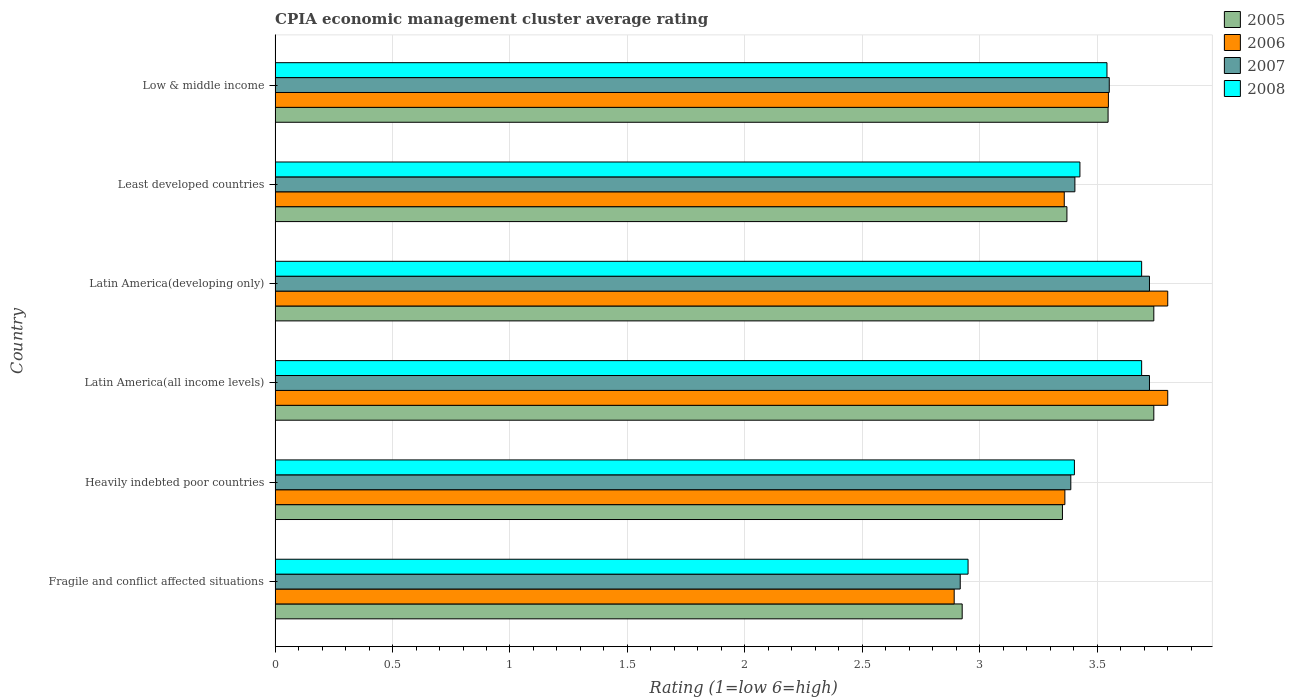How many groups of bars are there?
Make the answer very short. 6. Are the number of bars per tick equal to the number of legend labels?
Your answer should be very brief. Yes. Are the number of bars on each tick of the Y-axis equal?
Give a very brief answer. Yes. How many bars are there on the 6th tick from the top?
Your answer should be compact. 4. What is the CPIA rating in 2007 in Fragile and conflict affected situations?
Ensure brevity in your answer.  2.92. Across all countries, what is the maximum CPIA rating in 2008?
Give a very brief answer. 3.69. Across all countries, what is the minimum CPIA rating in 2007?
Give a very brief answer. 2.92. In which country was the CPIA rating in 2007 maximum?
Provide a short and direct response. Latin America(all income levels). In which country was the CPIA rating in 2005 minimum?
Provide a short and direct response. Fragile and conflict affected situations. What is the total CPIA rating in 2007 in the graph?
Offer a terse response. 20.7. What is the difference between the CPIA rating in 2008 in Heavily indebted poor countries and that in Least developed countries?
Your response must be concise. -0.02. What is the difference between the CPIA rating in 2006 in Fragile and conflict affected situations and the CPIA rating in 2008 in Least developed countries?
Offer a very short reply. -0.54. What is the average CPIA rating in 2005 per country?
Provide a short and direct response. 3.45. What is the difference between the CPIA rating in 2005 and CPIA rating in 2008 in Latin America(developing only)?
Your answer should be very brief. 0.05. What is the ratio of the CPIA rating in 2006 in Latin America(developing only) to that in Low & middle income?
Your answer should be very brief. 1.07. Is the difference between the CPIA rating in 2005 in Latin America(all income levels) and Low & middle income greater than the difference between the CPIA rating in 2008 in Latin America(all income levels) and Low & middle income?
Provide a succinct answer. Yes. What is the difference between the highest and the lowest CPIA rating in 2005?
Ensure brevity in your answer.  0.82. Is the sum of the CPIA rating in 2008 in Latin America(all income levels) and Least developed countries greater than the maximum CPIA rating in 2007 across all countries?
Your answer should be compact. Yes. Is it the case that in every country, the sum of the CPIA rating in 2006 and CPIA rating in 2008 is greater than the sum of CPIA rating in 2007 and CPIA rating in 2005?
Make the answer very short. No. What does the 4th bar from the top in Latin America(all income levels) represents?
Offer a terse response. 2005. What does the 3rd bar from the bottom in Low & middle income represents?
Make the answer very short. 2007. Does the graph contain any zero values?
Provide a succinct answer. No. How are the legend labels stacked?
Provide a succinct answer. Vertical. What is the title of the graph?
Your response must be concise. CPIA economic management cluster average rating. Does "2005" appear as one of the legend labels in the graph?
Provide a short and direct response. Yes. What is the Rating (1=low 6=high) of 2005 in Fragile and conflict affected situations?
Your answer should be very brief. 2.92. What is the Rating (1=low 6=high) of 2006 in Fragile and conflict affected situations?
Keep it short and to the point. 2.89. What is the Rating (1=low 6=high) in 2007 in Fragile and conflict affected situations?
Your response must be concise. 2.92. What is the Rating (1=low 6=high) in 2008 in Fragile and conflict affected situations?
Make the answer very short. 2.95. What is the Rating (1=low 6=high) in 2005 in Heavily indebted poor countries?
Give a very brief answer. 3.35. What is the Rating (1=low 6=high) of 2006 in Heavily indebted poor countries?
Provide a short and direct response. 3.36. What is the Rating (1=low 6=high) in 2007 in Heavily indebted poor countries?
Ensure brevity in your answer.  3.39. What is the Rating (1=low 6=high) in 2008 in Heavily indebted poor countries?
Make the answer very short. 3.4. What is the Rating (1=low 6=high) of 2005 in Latin America(all income levels)?
Keep it short and to the point. 3.74. What is the Rating (1=low 6=high) of 2006 in Latin America(all income levels)?
Your answer should be very brief. 3.8. What is the Rating (1=low 6=high) of 2007 in Latin America(all income levels)?
Provide a succinct answer. 3.72. What is the Rating (1=low 6=high) of 2008 in Latin America(all income levels)?
Ensure brevity in your answer.  3.69. What is the Rating (1=low 6=high) in 2005 in Latin America(developing only)?
Provide a succinct answer. 3.74. What is the Rating (1=low 6=high) in 2006 in Latin America(developing only)?
Your response must be concise. 3.8. What is the Rating (1=low 6=high) of 2007 in Latin America(developing only)?
Your answer should be compact. 3.72. What is the Rating (1=low 6=high) in 2008 in Latin America(developing only)?
Offer a terse response. 3.69. What is the Rating (1=low 6=high) of 2005 in Least developed countries?
Keep it short and to the point. 3.37. What is the Rating (1=low 6=high) of 2006 in Least developed countries?
Your response must be concise. 3.36. What is the Rating (1=low 6=high) in 2007 in Least developed countries?
Give a very brief answer. 3.4. What is the Rating (1=low 6=high) of 2008 in Least developed countries?
Make the answer very short. 3.43. What is the Rating (1=low 6=high) in 2005 in Low & middle income?
Keep it short and to the point. 3.55. What is the Rating (1=low 6=high) in 2006 in Low & middle income?
Your answer should be compact. 3.55. What is the Rating (1=low 6=high) in 2007 in Low & middle income?
Make the answer very short. 3.55. What is the Rating (1=low 6=high) in 2008 in Low & middle income?
Your answer should be very brief. 3.54. Across all countries, what is the maximum Rating (1=low 6=high) of 2005?
Your response must be concise. 3.74. Across all countries, what is the maximum Rating (1=low 6=high) of 2007?
Your answer should be very brief. 3.72. Across all countries, what is the maximum Rating (1=low 6=high) of 2008?
Your answer should be compact. 3.69. Across all countries, what is the minimum Rating (1=low 6=high) in 2005?
Provide a succinct answer. 2.92. Across all countries, what is the minimum Rating (1=low 6=high) of 2006?
Your response must be concise. 2.89. Across all countries, what is the minimum Rating (1=low 6=high) of 2007?
Your answer should be compact. 2.92. Across all countries, what is the minimum Rating (1=low 6=high) of 2008?
Give a very brief answer. 2.95. What is the total Rating (1=low 6=high) of 2005 in the graph?
Your response must be concise. 20.68. What is the total Rating (1=low 6=high) in 2006 in the graph?
Your answer should be very brief. 20.76. What is the total Rating (1=low 6=high) of 2007 in the graph?
Ensure brevity in your answer.  20.7. What is the total Rating (1=low 6=high) of 2008 in the graph?
Make the answer very short. 20.7. What is the difference between the Rating (1=low 6=high) in 2005 in Fragile and conflict affected situations and that in Heavily indebted poor countries?
Your answer should be very brief. -0.43. What is the difference between the Rating (1=low 6=high) of 2006 in Fragile and conflict affected situations and that in Heavily indebted poor countries?
Keep it short and to the point. -0.47. What is the difference between the Rating (1=low 6=high) of 2007 in Fragile and conflict affected situations and that in Heavily indebted poor countries?
Your response must be concise. -0.47. What is the difference between the Rating (1=low 6=high) in 2008 in Fragile and conflict affected situations and that in Heavily indebted poor countries?
Offer a very short reply. -0.45. What is the difference between the Rating (1=low 6=high) of 2005 in Fragile and conflict affected situations and that in Latin America(all income levels)?
Give a very brief answer. -0.82. What is the difference between the Rating (1=low 6=high) in 2006 in Fragile and conflict affected situations and that in Latin America(all income levels)?
Your answer should be compact. -0.91. What is the difference between the Rating (1=low 6=high) in 2007 in Fragile and conflict affected situations and that in Latin America(all income levels)?
Keep it short and to the point. -0.81. What is the difference between the Rating (1=low 6=high) of 2008 in Fragile and conflict affected situations and that in Latin America(all income levels)?
Make the answer very short. -0.74. What is the difference between the Rating (1=low 6=high) of 2005 in Fragile and conflict affected situations and that in Latin America(developing only)?
Make the answer very short. -0.82. What is the difference between the Rating (1=low 6=high) in 2006 in Fragile and conflict affected situations and that in Latin America(developing only)?
Your answer should be very brief. -0.91. What is the difference between the Rating (1=low 6=high) of 2007 in Fragile and conflict affected situations and that in Latin America(developing only)?
Give a very brief answer. -0.81. What is the difference between the Rating (1=low 6=high) in 2008 in Fragile and conflict affected situations and that in Latin America(developing only)?
Ensure brevity in your answer.  -0.74. What is the difference between the Rating (1=low 6=high) in 2005 in Fragile and conflict affected situations and that in Least developed countries?
Your answer should be compact. -0.45. What is the difference between the Rating (1=low 6=high) in 2006 in Fragile and conflict affected situations and that in Least developed countries?
Your answer should be compact. -0.47. What is the difference between the Rating (1=low 6=high) in 2007 in Fragile and conflict affected situations and that in Least developed countries?
Keep it short and to the point. -0.49. What is the difference between the Rating (1=low 6=high) of 2008 in Fragile and conflict affected situations and that in Least developed countries?
Provide a short and direct response. -0.48. What is the difference between the Rating (1=low 6=high) in 2005 in Fragile and conflict affected situations and that in Low & middle income?
Keep it short and to the point. -0.62. What is the difference between the Rating (1=low 6=high) of 2006 in Fragile and conflict affected situations and that in Low & middle income?
Provide a short and direct response. -0.66. What is the difference between the Rating (1=low 6=high) of 2007 in Fragile and conflict affected situations and that in Low & middle income?
Offer a terse response. -0.63. What is the difference between the Rating (1=low 6=high) in 2008 in Fragile and conflict affected situations and that in Low & middle income?
Keep it short and to the point. -0.59. What is the difference between the Rating (1=low 6=high) in 2005 in Heavily indebted poor countries and that in Latin America(all income levels)?
Give a very brief answer. -0.39. What is the difference between the Rating (1=low 6=high) in 2006 in Heavily indebted poor countries and that in Latin America(all income levels)?
Your response must be concise. -0.44. What is the difference between the Rating (1=low 6=high) in 2007 in Heavily indebted poor countries and that in Latin America(all income levels)?
Provide a short and direct response. -0.33. What is the difference between the Rating (1=low 6=high) of 2008 in Heavily indebted poor countries and that in Latin America(all income levels)?
Keep it short and to the point. -0.29. What is the difference between the Rating (1=low 6=high) in 2005 in Heavily indebted poor countries and that in Latin America(developing only)?
Offer a terse response. -0.39. What is the difference between the Rating (1=low 6=high) of 2006 in Heavily indebted poor countries and that in Latin America(developing only)?
Ensure brevity in your answer.  -0.44. What is the difference between the Rating (1=low 6=high) of 2007 in Heavily indebted poor countries and that in Latin America(developing only)?
Make the answer very short. -0.33. What is the difference between the Rating (1=low 6=high) of 2008 in Heavily indebted poor countries and that in Latin America(developing only)?
Your response must be concise. -0.29. What is the difference between the Rating (1=low 6=high) of 2005 in Heavily indebted poor countries and that in Least developed countries?
Give a very brief answer. -0.02. What is the difference between the Rating (1=low 6=high) of 2006 in Heavily indebted poor countries and that in Least developed countries?
Provide a short and direct response. 0. What is the difference between the Rating (1=low 6=high) in 2007 in Heavily indebted poor countries and that in Least developed countries?
Make the answer very short. -0.02. What is the difference between the Rating (1=low 6=high) in 2008 in Heavily indebted poor countries and that in Least developed countries?
Ensure brevity in your answer.  -0.02. What is the difference between the Rating (1=low 6=high) of 2005 in Heavily indebted poor countries and that in Low & middle income?
Provide a succinct answer. -0.19. What is the difference between the Rating (1=low 6=high) in 2006 in Heavily indebted poor countries and that in Low & middle income?
Ensure brevity in your answer.  -0.19. What is the difference between the Rating (1=low 6=high) in 2007 in Heavily indebted poor countries and that in Low & middle income?
Offer a very short reply. -0.16. What is the difference between the Rating (1=low 6=high) in 2008 in Heavily indebted poor countries and that in Low & middle income?
Ensure brevity in your answer.  -0.14. What is the difference between the Rating (1=low 6=high) of 2005 in Latin America(all income levels) and that in Latin America(developing only)?
Your answer should be very brief. 0. What is the difference between the Rating (1=low 6=high) of 2006 in Latin America(all income levels) and that in Latin America(developing only)?
Your answer should be very brief. 0. What is the difference between the Rating (1=low 6=high) in 2005 in Latin America(all income levels) and that in Least developed countries?
Provide a succinct answer. 0.37. What is the difference between the Rating (1=low 6=high) of 2006 in Latin America(all income levels) and that in Least developed countries?
Provide a short and direct response. 0.44. What is the difference between the Rating (1=low 6=high) in 2007 in Latin America(all income levels) and that in Least developed countries?
Offer a very short reply. 0.32. What is the difference between the Rating (1=low 6=high) of 2008 in Latin America(all income levels) and that in Least developed countries?
Offer a terse response. 0.26. What is the difference between the Rating (1=low 6=high) of 2005 in Latin America(all income levels) and that in Low & middle income?
Your answer should be very brief. 0.19. What is the difference between the Rating (1=low 6=high) in 2006 in Latin America(all income levels) and that in Low & middle income?
Provide a short and direct response. 0.25. What is the difference between the Rating (1=low 6=high) of 2007 in Latin America(all income levels) and that in Low & middle income?
Keep it short and to the point. 0.17. What is the difference between the Rating (1=low 6=high) of 2008 in Latin America(all income levels) and that in Low & middle income?
Your response must be concise. 0.15. What is the difference between the Rating (1=low 6=high) in 2005 in Latin America(developing only) and that in Least developed countries?
Provide a succinct answer. 0.37. What is the difference between the Rating (1=low 6=high) in 2006 in Latin America(developing only) and that in Least developed countries?
Offer a terse response. 0.44. What is the difference between the Rating (1=low 6=high) of 2007 in Latin America(developing only) and that in Least developed countries?
Provide a succinct answer. 0.32. What is the difference between the Rating (1=low 6=high) in 2008 in Latin America(developing only) and that in Least developed countries?
Your answer should be compact. 0.26. What is the difference between the Rating (1=low 6=high) of 2005 in Latin America(developing only) and that in Low & middle income?
Your response must be concise. 0.19. What is the difference between the Rating (1=low 6=high) of 2006 in Latin America(developing only) and that in Low & middle income?
Offer a terse response. 0.25. What is the difference between the Rating (1=low 6=high) of 2007 in Latin America(developing only) and that in Low & middle income?
Offer a terse response. 0.17. What is the difference between the Rating (1=low 6=high) in 2008 in Latin America(developing only) and that in Low & middle income?
Your answer should be compact. 0.15. What is the difference between the Rating (1=low 6=high) in 2005 in Least developed countries and that in Low & middle income?
Your response must be concise. -0.18. What is the difference between the Rating (1=low 6=high) of 2006 in Least developed countries and that in Low & middle income?
Your answer should be compact. -0.19. What is the difference between the Rating (1=low 6=high) of 2007 in Least developed countries and that in Low & middle income?
Provide a succinct answer. -0.15. What is the difference between the Rating (1=low 6=high) in 2008 in Least developed countries and that in Low & middle income?
Provide a short and direct response. -0.12. What is the difference between the Rating (1=low 6=high) in 2005 in Fragile and conflict affected situations and the Rating (1=low 6=high) in 2006 in Heavily indebted poor countries?
Provide a short and direct response. -0.44. What is the difference between the Rating (1=low 6=high) of 2005 in Fragile and conflict affected situations and the Rating (1=low 6=high) of 2007 in Heavily indebted poor countries?
Provide a short and direct response. -0.46. What is the difference between the Rating (1=low 6=high) in 2005 in Fragile and conflict affected situations and the Rating (1=low 6=high) in 2008 in Heavily indebted poor countries?
Ensure brevity in your answer.  -0.48. What is the difference between the Rating (1=low 6=high) of 2006 in Fragile and conflict affected situations and the Rating (1=low 6=high) of 2007 in Heavily indebted poor countries?
Make the answer very short. -0.5. What is the difference between the Rating (1=low 6=high) in 2006 in Fragile and conflict affected situations and the Rating (1=low 6=high) in 2008 in Heavily indebted poor countries?
Give a very brief answer. -0.51. What is the difference between the Rating (1=low 6=high) of 2007 in Fragile and conflict affected situations and the Rating (1=low 6=high) of 2008 in Heavily indebted poor countries?
Ensure brevity in your answer.  -0.49. What is the difference between the Rating (1=low 6=high) of 2005 in Fragile and conflict affected situations and the Rating (1=low 6=high) of 2006 in Latin America(all income levels)?
Provide a succinct answer. -0.88. What is the difference between the Rating (1=low 6=high) of 2005 in Fragile and conflict affected situations and the Rating (1=low 6=high) of 2007 in Latin America(all income levels)?
Offer a very short reply. -0.8. What is the difference between the Rating (1=low 6=high) of 2005 in Fragile and conflict affected situations and the Rating (1=low 6=high) of 2008 in Latin America(all income levels)?
Ensure brevity in your answer.  -0.76. What is the difference between the Rating (1=low 6=high) of 2006 in Fragile and conflict affected situations and the Rating (1=low 6=high) of 2007 in Latin America(all income levels)?
Give a very brief answer. -0.83. What is the difference between the Rating (1=low 6=high) of 2006 in Fragile and conflict affected situations and the Rating (1=low 6=high) of 2008 in Latin America(all income levels)?
Ensure brevity in your answer.  -0.8. What is the difference between the Rating (1=low 6=high) in 2007 in Fragile and conflict affected situations and the Rating (1=low 6=high) in 2008 in Latin America(all income levels)?
Offer a very short reply. -0.77. What is the difference between the Rating (1=low 6=high) in 2005 in Fragile and conflict affected situations and the Rating (1=low 6=high) in 2006 in Latin America(developing only)?
Offer a terse response. -0.88. What is the difference between the Rating (1=low 6=high) of 2005 in Fragile and conflict affected situations and the Rating (1=low 6=high) of 2007 in Latin America(developing only)?
Provide a succinct answer. -0.8. What is the difference between the Rating (1=low 6=high) in 2005 in Fragile and conflict affected situations and the Rating (1=low 6=high) in 2008 in Latin America(developing only)?
Make the answer very short. -0.76. What is the difference between the Rating (1=low 6=high) of 2006 in Fragile and conflict affected situations and the Rating (1=low 6=high) of 2007 in Latin America(developing only)?
Your answer should be compact. -0.83. What is the difference between the Rating (1=low 6=high) in 2006 in Fragile and conflict affected situations and the Rating (1=low 6=high) in 2008 in Latin America(developing only)?
Your answer should be very brief. -0.8. What is the difference between the Rating (1=low 6=high) of 2007 in Fragile and conflict affected situations and the Rating (1=low 6=high) of 2008 in Latin America(developing only)?
Your response must be concise. -0.77. What is the difference between the Rating (1=low 6=high) in 2005 in Fragile and conflict affected situations and the Rating (1=low 6=high) in 2006 in Least developed countries?
Provide a short and direct response. -0.43. What is the difference between the Rating (1=low 6=high) in 2005 in Fragile and conflict affected situations and the Rating (1=low 6=high) in 2007 in Least developed countries?
Your answer should be compact. -0.48. What is the difference between the Rating (1=low 6=high) in 2005 in Fragile and conflict affected situations and the Rating (1=low 6=high) in 2008 in Least developed countries?
Keep it short and to the point. -0.5. What is the difference between the Rating (1=low 6=high) in 2006 in Fragile and conflict affected situations and the Rating (1=low 6=high) in 2007 in Least developed countries?
Your answer should be very brief. -0.51. What is the difference between the Rating (1=low 6=high) in 2006 in Fragile and conflict affected situations and the Rating (1=low 6=high) in 2008 in Least developed countries?
Ensure brevity in your answer.  -0.54. What is the difference between the Rating (1=low 6=high) of 2007 in Fragile and conflict affected situations and the Rating (1=low 6=high) of 2008 in Least developed countries?
Provide a short and direct response. -0.51. What is the difference between the Rating (1=low 6=high) in 2005 in Fragile and conflict affected situations and the Rating (1=low 6=high) in 2006 in Low & middle income?
Provide a short and direct response. -0.62. What is the difference between the Rating (1=low 6=high) of 2005 in Fragile and conflict affected situations and the Rating (1=low 6=high) of 2007 in Low & middle income?
Give a very brief answer. -0.63. What is the difference between the Rating (1=low 6=high) in 2005 in Fragile and conflict affected situations and the Rating (1=low 6=high) in 2008 in Low & middle income?
Provide a succinct answer. -0.62. What is the difference between the Rating (1=low 6=high) in 2006 in Fragile and conflict affected situations and the Rating (1=low 6=high) in 2007 in Low & middle income?
Offer a terse response. -0.66. What is the difference between the Rating (1=low 6=high) of 2006 in Fragile and conflict affected situations and the Rating (1=low 6=high) of 2008 in Low & middle income?
Your answer should be very brief. -0.65. What is the difference between the Rating (1=low 6=high) of 2007 in Fragile and conflict affected situations and the Rating (1=low 6=high) of 2008 in Low & middle income?
Give a very brief answer. -0.62. What is the difference between the Rating (1=low 6=high) in 2005 in Heavily indebted poor countries and the Rating (1=low 6=high) in 2006 in Latin America(all income levels)?
Ensure brevity in your answer.  -0.45. What is the difference between the Rating (1=low 6=high) of 2005 in Heavily indebted poor countries and the Rating (1=low 6=high) of 2007 in Latin America(all income levels)?
Give a very brief answer. -0.37. What is the difference between the Rating (1=low 6=high) in 2005 in Heavily indebted poor countries and the Rating (1=low 6=high) in 2008 in Latin America(all income levels)?
Keep it short and to the point. -0.34. What is the difference between the Rating (1=low 6=high) in 2006 in Heavily indebted poor countries and the Rating (1=low 6=high) in 2007 in Latin America(all income levels)?
Ensure brevity in your answer.  -0.36. What is the difference between the Rating (1=low 6=high) of 2006 in Heavily indebted poor countries and the Rating (1=low 6=high) of 2008 in Latin America(all income levels)?
Provide a succinct answer. -0.33. What is the difference between the Rating (1=low 6=high) in 2007 in Heavily indebted poor countries and the Rating (1=low 6=high) in 2008 in Latin America(all income levels)?
Ensure brevity in your answer.  -0.3. What is the difference between the Rating (1=low 6=high) of 2005 in Heavily indebted poor countries and the Rating (1=low 6=high) of 2006 in Latin America(developing only)?
Ensure brevity in your answer.  -0.45. What is the difference between the Rating (1=low 6=high) in 2005 in Heavily indebted poor countries and the Rating (1=low 6=high) in 2007 in Latin America(developing only)?
Provide a succinct answer. -0.37. What is the difference between the Rating (1=low 6=high) in 2005 in Heavily indebted poor countries and the Rating (1=low 6=high) in 2008 in Latin America(developing only)?
Ensure brevity in your answer.  -0.34. What is the difference between the Rating (1=low 6=high) of 2006 in Heavily indebted poor countries and the Rating (1=low 6=high) of 2007 in Latin America(developing only)?
Your answer should be very brief. -0.36. What is the difference between the Rating (1=low 6=high) in 2006 in Heavily indebted poor countries and the Rating (1=low 6=high) in 2008 in Latin America(developing only)?
Offer a terse response. -0.33. What is the difference between the Rating (1=low 6=high) in 2007 in Heavily indebted poor countries and the Rating (1=low 6=high) in 2008 in Latin America(developing only)?
Offer a terse response. -0.3. What is the difference between the Rating (1=low 6=high) in 2005 in Heavily indebted poor countries and the Rating (1=low 6=high) in 2006 in Least developed countries?
Provide a succinct answer. -0.01. What is the difference between the Rating (1=low 6=high) of 2005 in Heavily indebted poor countries and the Rating (1=low 6=high) of 2007 in Least developed countries?
Offer a terse response. -0.05. What is the difference between the Rating (1=low 6=high) of 2005 in Heavily indebted poor countries and the Rating (1=low 6=high) of 2008 in Least developed countries?
Your response must be concise. -0.07. What is the difference between the Rating (1=low 6=high) of 2006 in Heavily indebted poor countries and the Rating (1=low 6=high) of 2007 in Least developed countries?
Your answer should be very brief. -0.04. What is the difference between the Rating (1=low 6=high) in 2006 in Heavily indebted poor countries and the Rating (1=low 6=high) in 2008 in Least developed countries?
Ensure brevity in your answer.  -0.06. What is the difference between the Rating (1=low 6=high) in 2007 in Heavily indebted poor countries and the Rating (1=low 6=high) in 2008 in Least developed countries?
Give a very brief answer. -0.04. What is the difference between the Rating (1=low 6=high) in 2005 in Heavily indebted poor countries and the Rating (1=low 6=high) in 2006 in Low & middle income?
Your answer should be compact. -0.2. What is the difference between the Rating (1=low 6=high) of 2005 in Heavily indebted poor countries and the Rating (1=low 6=high) of 2007 in Low & middle income?
Ensure brevity in your answer.  -0.2. What is the difference between the Rating (1=low 6=high) in 2005 in Heavily indebted poor countries and the Rating (1=low 6=high) in 2008 in Low & middle income?
Make the answer very short. -0.19. What is the difference between the Rating (1=low 6=high) of 2006 in Heavily indebted poor countries and the Rating (1=low 6=high) of 2007 in Low & middle income?
Make the answer very short. -0.19. What is the difference between the Rating (1=low 6=high) of 2006 in Heavily indebted poor countries and the Rating (1=low 6=high) of 2008 in Low & middle income?
Give a very brief answer. -0.18. What is the difference between the Rating (1=low 6=high) of 2007 in Heavily indebted poor countries and the Rating (1=low 6=high) of 2008 in Low & middle income?
Provide a short and direct response. -0.15. What is the difference between the Rating (1=low 6=high) in 2005 in Latin America(all income levels) and the Rating (1=low 6=high) in 2006 in Latin America(developing only)?
Offer a terse response. -0.06. What is the difference between the Rating (1=low 6=high) in 2005 in Latin America(all income levels) and the Rating (1=low 6=high) in 2007 in Latin America(developing only)?
Your answer should be compact. 0.02. What is the difference between the Rating (1=low 6=high) in 2005 in Latin America(all income levels) and the Rating (1=low 6=high) in 2008 in Latin America(developing only)?
Ensure brevity in your answer.  0.05. What is the difference between the Rating (1=low 6=high) in 2006 in Latin America(all income levels) and the Rating (1=low 6=high) in 2007 in Latin America(developing only)?
Your answer should be compact. 0.08. What is the difference between the Rating (1=low 6=high) in 2005 in Latin America(all income levels) and the Rating (1=low 6=high) in 2006 in Least developed countries?
Offer a terse response. 0.38. What is the difference between the Rating (1=low 6=high) in 2005 in Latin America(all income levels) and the Rating (1=low 6=high) in 2007 in Least developed countries?
Make the answer very short. 0.34. What is the difference between the Rating (1=low 6=high) in 2005 in Latin America(all income levels) and the Rating (1=low 6=high) in 2008 in Least developed countries?
Your response must be concise. 0.31. What is the difference between the Rating (1=low 6=high) of 2006 in Latin America(all income levels) and the Rating (1=low 6=high) of 2007 in Least developed countries?
Offer a terse response. 0.4. What is the difference between the Rating (1=low 6=high) in 2006 in Latin America(all income levels) and the Rating (1=low 6=high) in 2008 in Least developed countries?
Your answer should be compact. 0.37. What is the difference between the Rating (1=low 6=high) of 2007 in Latin America(all income levels) and the Rating (1=low 6=high) of 2008 in Least developed countries?
Your answer should be very brief. 0.3. What is the difference between the Rating (1=low 6=high) of 2005 in Latin America(all income levels) and the Rating (1=low 6=high) of 2006 in Low & middle income?
Your answer should be very brief. 0.19. What is the difference between the Rating (1=low 6=high) of 2005 in Latin America(all income levels) and the Rating (1=low 6=high) of 2007 in Low & middle income?
Provide a succinct answer. 0.19. What is the difference between the Rating (1=low 6=high) of 2005 in Latin America(all income levels) and the Rating (1=low 6=high) of 2008 in Low & middle income?
Your response must be concise. 0.2. What is the difference between the Rating (1=low 6=high) of 2006 in Latin America(all income levels) and the Rating (1=low 6=high) of 2007 in Low & middle income?
Your response must be concise. 0.25. What is the difference between the Rating (1=low 6=high) of 2006 in Latin America(all income levels) and the Rating (1=low 6=high) of 2008 in Low & middle income?
Your answer should be very brief. 0.26. What is the difference between the Rating (1=low 6=high) of 2007 in Latin America(all income levels) and the Rating (1=low 6=high) of 2008 in Low & middle income?
Give a very brief answer. 0.18. What is the difference between the Rating (1=low 6=high) in 2005 in Latin America(developing only) and the Rating (1=low 6=high) in 2006 in Least developed countries?
Your answer should be compact. 0.38. What is the difference between the Rating (1=low 6=high) in 2005 in Latin America(developing only) and the Rating (1=low 6=high) in 2007 in Least developed countries?
Your answer should be very brief. 0.34. What is the difference between the Rating (1=low 6=high) of 2005 in Latin America(developing only) and the Rating (1=low 6=high) of 2008 in Least developed countries?
Provide a short and direct response. 0.31. What is the difference between the Rating (1=low 6=high) of 2006 in Latin America(developing only) and the Rating (1=low 6=high) of 2007 in Least developed countries?
Ensure brevity in your answer.  0.4. What is the difference between the Rating (1=low 6=high) in 2006 in Latin America(developing only) and the Rating (1=low 6=high) in 2008 in Least developed countries?
Provide a short and direct response. 0.37. What is the difference between the Rating (1=low 6=high) in 2007 in Latin America(developing only) and the Rating (1=low 6=high) in 2008 in Least developed countries?
Your answer should be compact. 0.3. What is the difference between the Rating (1=low 6=high) in 2005 in Latin America(developing only) and the Rating (1=low 6=high) in 2006 in Low & middle income?
Provide a short and direct response. 0.19. What is the difference between the Rating (1=low 6=high) of 2005 in Latin America(developing only) and the Rating (1=low 6=high) of 2007 in Low & middle income?
Make the answer very short. 0.19. What is the difference between the Rating (1=low 6=high) in 2005 in Latin America(developing only) and the Rating (1=low 6=high) in 2008 in Low & middle income?
Offer a very short reply. 0.2. What is the difference between the Rating (1=low 6=high) in 2006 in Latin America(developing only) and the Rating (1=low 6=high) in 2007 in Low & middle income?
Provide a short and direct response. 0.25. What is the difference between the Rating (1=low 6=high) of 2006 in Latin America(developing only) and the Rating (1=low 6=high) of 2008 in Low & middle income?
Offer a very short reply. 0.26. What is the difference between the Rating (1=low 6=high) of 2007 in Latin America(developing only) and the Rating (1=low 6=high) of 2008 in Low & middle income?
Keep it short and to the point. 0.18. What is the difference between the Rating (1=low 6=high) in 2005 in Least developed countries and the Rating (1=low 6=high) in 2006 in Low & middle income?
Your answer should be very brief. -0.18. What is the difference between the Rating (1=low 6=high) in 2005 in Least developed countries and the Rating (1=low 6=high) in 2007 in Low & middle income?
Your answer should be very brief. -0.18. What is the difference between the Rating (1=low 6=high) in 2005 in Least developed countries and the Rating (1=low 6=high) in 2008 in Low & middle income?
Provide a short and direct response. -0.17. What is the difference between the Rating (1=low 6=high) in 2006 in Least developed countries and the Rating (1=low 6=high) in 2007 in Low & middle income?
Give a very brief answer. -0.19. What is the difference between the Rating (1=low 6=high) in 2006 in Least developed countries and the Rating (1=low 6=high) in 2008 in Low & middle income?
Offer a very short reply. -0.18. What is the difference between the Rating (1=low 6=high) in 2007 in Least developed countries and the Rating (1=low 6=high) in 2008 in Low & middle income?
Your answer should be compact. -0.14. What is the average Rating (1=low 6=high) in 2005 per country?
Keep it short and to the point. 3.45. What is the average Rating (1=low 6=high) of 2006 per country?
Provide a succinct answer. 3.46. What is the average Rating (1=low 6=high) in 2007 per country?
Provide a short and direct response. 3.45. What is the average Rating (1=low 6=high) in 2008 per country?
Provide a succinct answer. 3.45. What is the difference between the Rating (1=low 6=high) in 2005 and Rating (1=low 6=high) in 2006 in Fragile and conflict affected situations?
Provide a succinct answer. 0.03. What is the difference between the Rating (1=low 6=high) of 2005 and Rating (1=low 6=high) of 2007 in Fragile and conflict affected situations?
Your response must be concise. 0.01. What is the difference between the Rating (1=low 6=high) in 2005 and Rating (1=low 6=high) in 2008 in Fragile and conflict affected situations?
Your answer should be very brief. -0.03. What is the difference between the Rating (1=low 6=high) in 2006 and Rating (1=low 6=high) in 2007 in Fragile and conflict affected situations?
Make the answer very short. -0.03. What is the difference between the Rating (1=low 6=high) in 2006 and Rating (1=low 6=high) in 2008 in Fragile and conflict affected situations?
Offer a very short reply. -0.06. What is the difference between the Rating (1=low 6=high) of 2007 and Rating (1=low 6=high) of 2008 in Fragile and conflict affected situations?
Offer a very short reply. -0.03. What is the difference between the Rating (1=low 6=high) of 2005 and Rating (1=low 6=high) of 2006 in Heavily indebted poor countries?
Offer a very short reply. -0.01. What is the difference between the Rating (1=low 6=high) of 2005 and Rating (1=low 6=high) of 2007 in Heavily indebted poor countries?
Keep it short and to the point. -0.04. What is the difference between the Rating (1=low 6=high) in 2005 and Rating (1=low 6=high) in 2008 in Heavily indebted poor countries?
Your answer should be compact. -0.05. What is the difference between the Rating (1=low 6=high) in 2006 and Rating (1=low 6=high) in 2007 in Heavily indebted poor countries?
Provide a succinct answer. -0.03. What is the difference between the Rating (1=low 6=high) in 2006 and Rating (1=low 6=high) in 2008 in Heavily indebted poor countries?
Ensure brevity in your answer.  -0.04. What is the difference between the Rating (1=low 6=high) in 2007 and Rating (1=low 6=high) in 2008 in Heavily indebted poor countries?
Offer a terse response. -0.02. What is the difference between the Rating (1=low 6=high) in 2005 and Rating (1=low 6=high) in 2006 in Latin America(all income levels)?
Your response must be concise. -0.06. What is the difference between the Rating (1=low 6=high) in 2005 and Rating (1=low 6=high) in 2007 in Latin America(all income levels)?
Your response must be concise. 0.02. What is the difference between the Rating (1=low 6=high) in 2005 and Rating (1=low 6=high) in 2008 in Latin America(all income levels)?
Ensure brevity in your answer.  0.05. What is the difference between the Rating (1=low 6=high) of 2006 and Rating (1=low 6=high) of 2007 in Latin America(all income levels)?
Your answer should be compact. 0.08. What is the difference between the Rating (1=low 6=high) of 2005 and Rating (1=low 6=high) of 2006 in Latin America(developing only)?
Your answer should be very brief. -0.06. What is the difference between the Rating (1=low 6=high) in 2005 and Rating (1=low 6=high) in 2007 in Latin America(developing only)?
Keep it short and to the point. 0.02. What is the difference between the Rating (1=low 6=high) of 2005 and Rating (1=low 6=high) of 2008 in Latin America(developing only)?
Your response must be concise. 0.05. What is the difference between the Rating (1=low 6=high) in 2006 and Rating (1=low 6=high) in 2007 in Latin America(developing only)?
Make the answer very short. 0.08. What is the difference between the Rating (1=low 6=high) of 2006 and Rating (1=low 6=high) of 2008 in Latin America(developing only)?
Provide a short and direct response. 0.11. What is the difference between the Rating (1=low 6=high) of 2007 and Rating (1=low 6=high) of 2008 in Latin America(developing only)?
Provide a short and direct response. 0.03. What is the difference between the Rating (1=low 6=high) in 2005 and Rating (1=low 6=high) in 2006 in Least developed countries?
Provide a succinct answer. 0.01. What is the difference between the Rating (1=low 6=high) of 2005 and Rating (1=low 6=high) of 2007 in Least developed countries?
Offer a very short reply. -0.03. What is the difference between the Rating (1=low 6=high) of 2005 and Rating (1=low 6=high) of 2008 in Least developed countries?
Offer a very short reply. -0.06. What is the difference between the Rating (1=low 6=high) in 2006 and Rating (1=low 6=high) in 2007 in Least developed countries?
Make the answer very short. -0.05. What is the difference between the Rating (1=low 6=high) of 2006 and Rating (1=low 6=high) of 2008 in Least developed countries?
Offer a terse response. -0.07. What is the difference between the Rating (1=low 6=high) of 2007 and Rating (1=low 6=high) of 2008 in Least developed countries?
Offer a very short reply. -0.02. What is the difference between the Rating (1=low 6=high) of 2005 and Rating (1=low 6=high) of 2006 in Low & middle income?
Keep it short and to the point. -0. What is the difference between the Rating (1=low 6=high) of 2005 and Rating (1=low 6=high) of 2007 in Low & middle income?
Offer a very short reply. -0.01. What is the difference between the Rating (1=low 6=high) in 2005 and Rating (1=low 6=high) in 2008 in Low & middle income?
Offer a very short reply. 0. What is the difference between the Rating (1=low 6=high) of 2006 and Rating (1=low 6=high) of 2007 in Low & middle income?
Provide a short and direct response. -0. What is the difference between the Rating (1=low 6=high) in 2006 and Rating (1=low 6=high) in 2008 in Low & middle income?
Offer a very short reply. 0.01. What is the difference between the Rating (1=low 6=high) of 2007 and Rating (1=low 6=high) of 2008 in Low & middle income?
Your answer should be compact. 0.01. What is the ratio of the Rating (1=low 6=high) in 2005 in Fragile and conflict affected situations to that in Heavily indebted poor countries?
Provide a succinct answer. 0.87. What is the ratio of the Rating (1=low 6=high) of 2006 in Fragile and conflict affected situations to that in Heavily indebted poor countries?
Offer a terse response. 0.86. What is the ratio of the Rating (1=low 6=high) of 2007 in Fragile and conflict affected situations to that in Heavily indebted poor countries?
Provide a short and direct response. 0.86. What is the ratio of the Rating (1=low 6=high) in 2008 in Fragile and conflict affected situations to that in Heavily indebted poor countries?
Make the answer very short. 0.87. What is the ratio of the Rating (1=low 6=high) of 2005 in Fragile and conflict affected situations to that in Latin America(all income levels)?
Offer a very short reply. 0.78. What is the ratio of the Rating (1=low 6=high) of 2006 in Fragile and conflict affected situations to that in Latin America(all income levels)?
Your response must be concise. 0.76. What is the ratio of the Rating (1=low 6=high) of 2007 in Fragile and conflict affected situations to that in Latin America(all income levels)?
Provide a short and direct response. 0.78. What is the ratio of the Rating (1=low 6=high) in 2008 in Fragile and conflict affected situations to that in Latin America(all income levels)?
Ensure brevity in your answer.  0.8. What is the ratio of the Rating (1=low 6=high) in 2005 in Fragile and conflict affected situations to that in Latin America(developing only)?
Provide a short and direct response. 0.78. What is the ratio of the Rating (1=low 6=high) in 2006 in Fragile and conflict affected situations to that in Latin America(developing only)?
Your response must be concise. 0.76. What is the ratio of the Rating (1=low 6=high) of 2007 in Fragile and conflict affected situations to that in Latin America(developing only)?
Your answer should be very brief. 0.78. What is the ratio of the Rating (1=low 6=high) in 2008 in Fragile and conflict affected situations to that in Latin America(developing only)?
Make the answer very short. 0.8. What is the ratio of the Rating (1=low 6=high) in 2005 in Fragile and conflict affected situations to that in Least developed countries?
Keep it short and to the point. 0.87. What is the ratio of the Rating (1=low 6=high) in 2006 in Fragile and conflict affected situations to that in Least developed countries?
Your answer should be very brief. 0.86. What is the ratio of the Rating (1=low 6=high) of 2007 in Fragile and conflict affected situations to that in Least developed countries?
Your answer should be very brief. 0.86. What is the ratio of the Rating (1=low 6=high) of 2008 in Fragile and conflict affected situations to that in Least developed countries?
Your answer should be compact. 0.86. What is the ratio of the Rating (1=low 6=high) in 2005 in Fragile and conflict affected situations to that in Low & middle income?
Offer a very short reply. 0.82. What is the ratio of the Rating (1=low 6=high) of 2006 in Fragile and conflict affected situations to that in Low & middle income?
Provide a succinct answer. 0.81. What is the ratio of the Rating (1=low 6=high) in 2007 in Fragile and conflict affected situations to that in Low & middle income?
Ensure brevity in your answer.  0.82. What is the ratio of the Rating (1=low 6=high) of 2008 in Fragile and conflict affected situations to that in Low & middle income?
Your answer should be compact. 0.83. What is the ratio of the Rating (1=low 6=high) in 2005 in Heavily indebted poor countries to that in Latin America(all income levels)?
Your response must be concise. 0.9. What is the ratio of the Rating (1=low 6=high) in 2006 in Heavily indebted poor countries to that in Latin America(all income levels)?
Offer a terse response. 0.88. What is the ratio of the Rating (1=low 6=high) in 2007 in Heavily indebted poor countries to that in Latin America(all income levels)?
Ensure brevity in your answer.  0.91. What is the ratio of the Rating (1=low 6=high) in 2008 in Heavily indebted poor countries to that in Latin America(all income levels)?
Make the answer very short. 0.92. What is the ratio of the Rating (1=low 6=high) of 2005 in Heavily indebted poor countries to that in Latin America(developing only)?
Provide a short and direct response. 0.9. What is the ratio of the Rating (1=low 6=high) in 2006 in Heavily indebted poor countries to that in Latin America(developing only)?
Give a very brief answer. 0.88. What is the ratio of the Rating (1=low 6=high) in 2007 in Heavily indebted poor countries to that in Latin America(developing only)?
Provide a succinct answer. 0.91. What is the ratio of the Rating (1=low 6=high) in 2008 in Heavily indebted poor countries to that in Latin America(developing only)?
Ensure brevity in your answer.  0.92. What is the ratio of the Rating (1=low 6=high) in 2005 in Heavily indebted poor countries to that in Least developed countries?
Keep it short and to the point. 0.99. What is the ratio of the Rating (1=low 6=high) in 2005 in Heavily indebted poor countries to that in Low & middle income?
Provide a succinct answer. 0.95. What is the ratio of the Rating (1=low 6=high) in 2006 in Heavily indebted poor countries to that in Low & middle income?
Your answer should be compact. 0.95. What is the ratio of the Rating (1=low 6=high) of 2007 in Heavily indebted poor countries to that in Low & middle income?
Keep it short and to the point. 0.95. What is the ratio of the Rating (1=low 6=high) in 2008 in Heavily indebted poor countries to that in Low & middle income?
Offer a very short reply. 0.96. What is the ratio of the Rating (1=low 6=high) of 2007 in Latin America(all income levels) to that in Latin America(developing only)?
Offer a terse response. 1. What is the ratio of the Rating (1=low 6=high) in 2008 in Latin America(all income levels) to that in Latin America(developing only)?
Your answer should be compact. 1. What is the ratio of the Rating (1=low 6=high) in 2005 in Latin America(all income levels) to that in Least developed countries?
Provide a succinct answer. 1.11. What is the ratio of the Rating (1=low 6=high) of 2006 in Latin America(all income levels) to that in Least developed countries?
Your answer should be compact. 1.13. What is the ratio of the Rating (1=low 6=high) of 2007 in Latin America(all income levels) to that in Least developed countries?
Give a very brief answer. 1.09. What is the ratio of the Rating (1=low 6=high) of 2008 in Latin America(all income levels) to that in Least developed countries?
Offer a terse response. 1.08. What is the ratio of the Rating (1=low 6=high) of 2005 in Latin America(all income levels) to that in Low & middle income?
Offer a terse response. 1.05. What is the ratio of the Rating (1=low 6=high) of 2006 in Latin America(all income levels) to that in Low & middle income?
Your answer should be compact. 1.07. What is the ratio of the Rating (1=low 6=high) of 2007 in Latin America(all income levels) to that in Low & middle income?
Your response must be concise. 1.05. What is the ratio of the Rating (1=low 6=high) in 2008 in Latin America(all income levels) to that in Low & middle income?
Provide a succinct answer. 1.04. What is the ratio of the Rating (1=low 6=high) of 2005 in Latin America(developing only) to that in Least developed countries?
Provide a short and direct response. 1.11. What is the ratio of the Rating (1=low 6=high) of 2006 in Latin America(developing only) to that in Least developed countries?
Your response must be concise. 1.13. What is the ratio of the Rating (1=low 6=high) in 2007 in Latin America(developing only) to that in Least developed countries?
Provide a succinct answer. 1.09. What is the ratio of the Rating (1=low 6=high) in 2008 in Latin America(developing only) to that in Least developed countries?
Provide a succinct answer. 1.08. What is the ratio of the Rating (1=low 6=high) of 2005 in Latin America(developing only) to that in Low & middle income?
Offer a terse response. 1.05. What is the ratio of the Rating (1=low 6=high) in 2006 in Latin America(developing only) to that in Low & middle income?
Give a very brief answer. 1.07. What is the ratio of the Rating (1=low 6=high) in 2007 in Latin America(developing only) to that in Low & middle income?
Make the answer very short. 1.05. What is the ratio of the Rating (1=low 6=high) in 2008 in Latin America(developing only) to that in Low & middle income?
Provide a succinct answer. 1.04. What is the ratio of the Rating (1=low 6=high) of 2005 in Least developed countries to that in Low & middle income?
Your answer should be compact. 0.95. What is the ratio of the Rating (1=low 6=high) of 2006 in Least developed countries to that in Low & middle income?
Provide a short and direct response. 0.95. What is the ratio of the Rating (1=low 6=high) in 2007 in Least developed countries to that in Low & middle income?
Your response must be concise. 0.96. What is the ratio of the Rating (1=low 6=high) of 2008 in Least developed countries to that in Low & middle income?
Your answer should be very brief. 0.97. What is the difference between the highest and the second highest Rating (1=low 6=high) in 2006?
Provide a short and direct response. 0. What is the difference between the highest and the lowest Rating (1=low 6=high) in 2005?
Your response must be concise. 0.82. What is the difference between the highest and the lowest Rating (1=low 6=high) of 2007?
Ensure brevity in your answer.  0.81. What is the difference between the highest and the lowest Rating (1=low 6=high) of 2008?
Give a very brief answer. 0.74. 